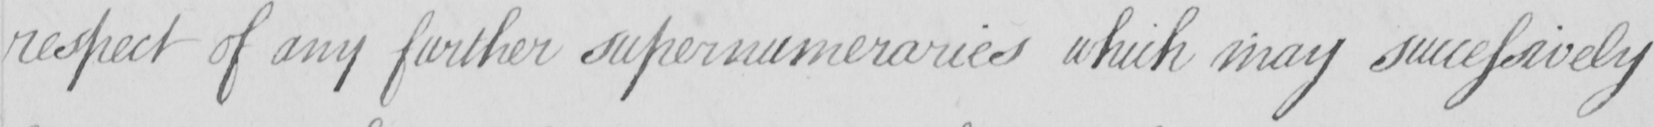What is written in this line of handwriting? respect of any further supernumeraries which may successively 